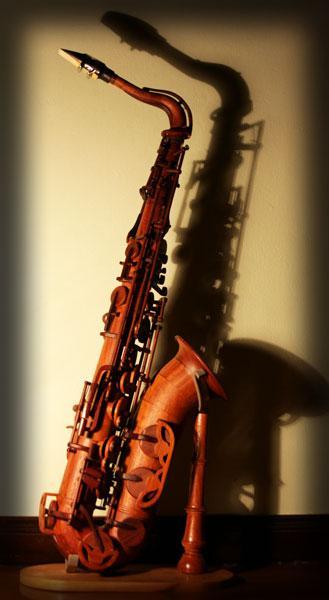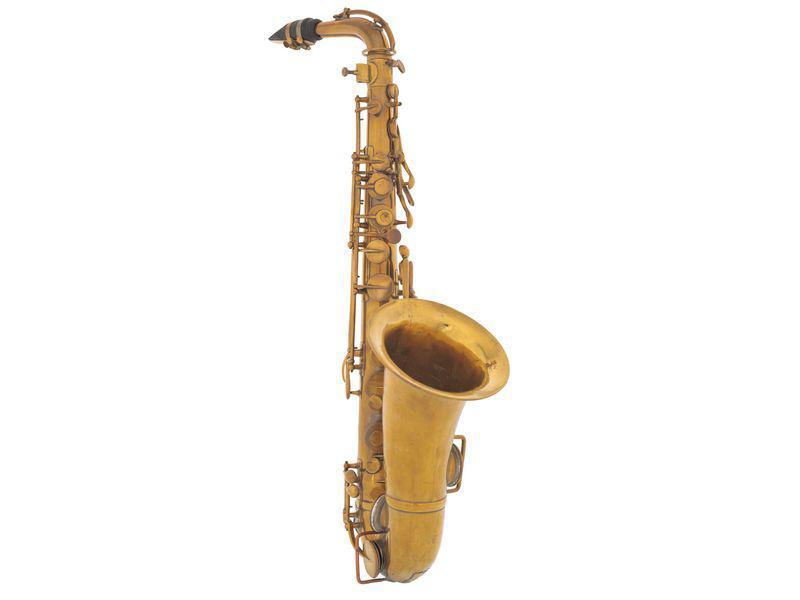The first image is the image on the left, the second image is the image on the right. Evaluate the accuracy of this statement regarding the images: "The saxophone in the image on the left is on a stand.". Is it true? Answer yes or no. Yes. The first image is the image on the left, the second image is the image on the right. Considering the images on both sides, is "The left image shows one instrument displayed on a wooden stand." valid? Answer yes or no. Yes. 